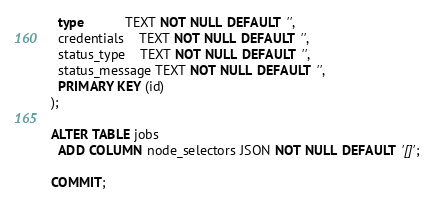Convert code to text. <code><loc_0><loc_0><loc_500><loc_500><_SQL_>  type           TEXT NOT NULL DEFAULT '',
  credentials    TEXT NOT NULL DEFAULT '',
  status_type    TEXT NOT NULL DEFAULT '',
  status_message TEXT NOT NULL DEFAULT '',
  PRIMARY KEY (id)
);

ALTER TABLE jobs
  ADD COLUMN node_selectors JSON NOT NULL DEFAULT '[]';

COMMIT;
</code> 